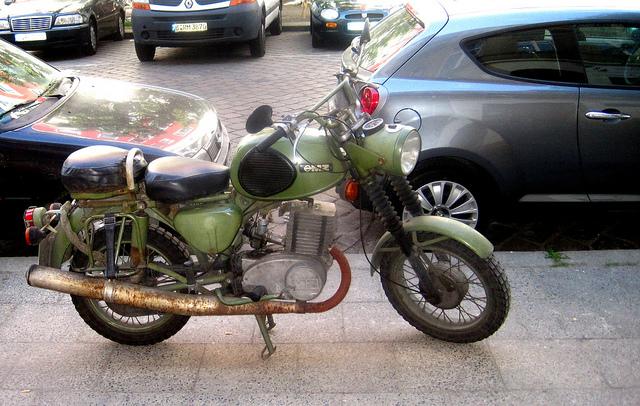How many cars are in this picture?
Keep it brief. 5. Do you think this is a vintage motorcycle?
Quick response, please. Yes. What is reflecting in the hood of the car?
Answer briefly. Tree. What are the motorcycles sitting on?
Answer briefly. Sidewalk. How many mufflers does the bike have?
Give a very brief answer. 1. 